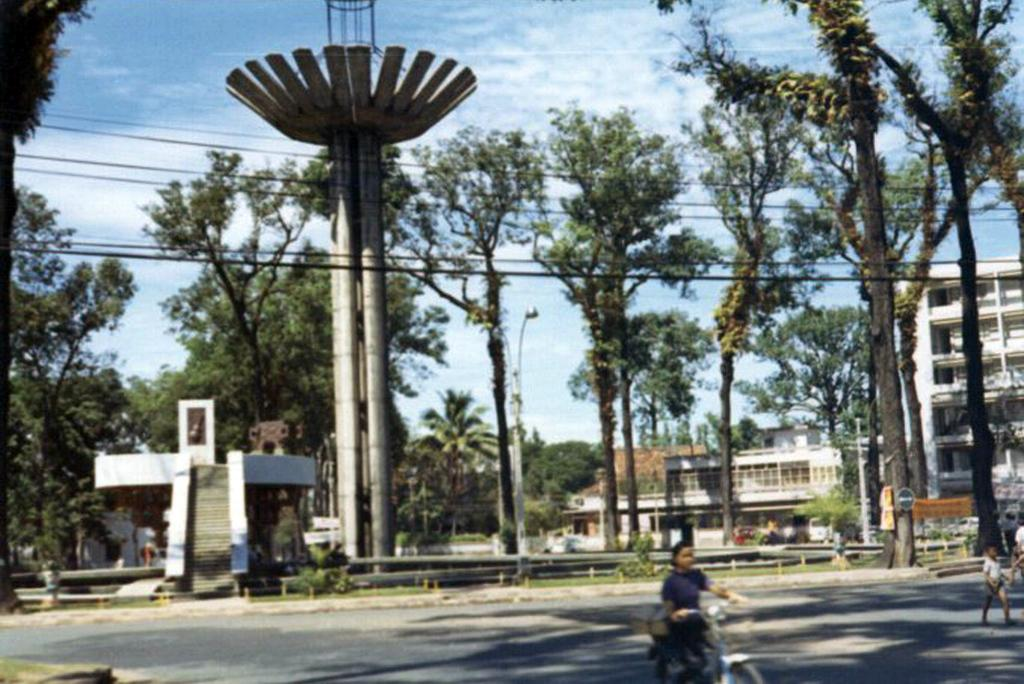How many people are present in the image? There are three people in the image. What are the people doing in the image? One person is riding a bicycle. What type of vegetation can be seen in the image? There are trees and plants in the image. What structures are visible in the image? There is a pole, buildings, and wires in the image. What part of the natural environment is visible in the image? The sky is visible in the image. What type of island can be seen in the image? There is no island present in the image. How does the parent in the image express their anger? There is no parent or expression of anger in the image. 